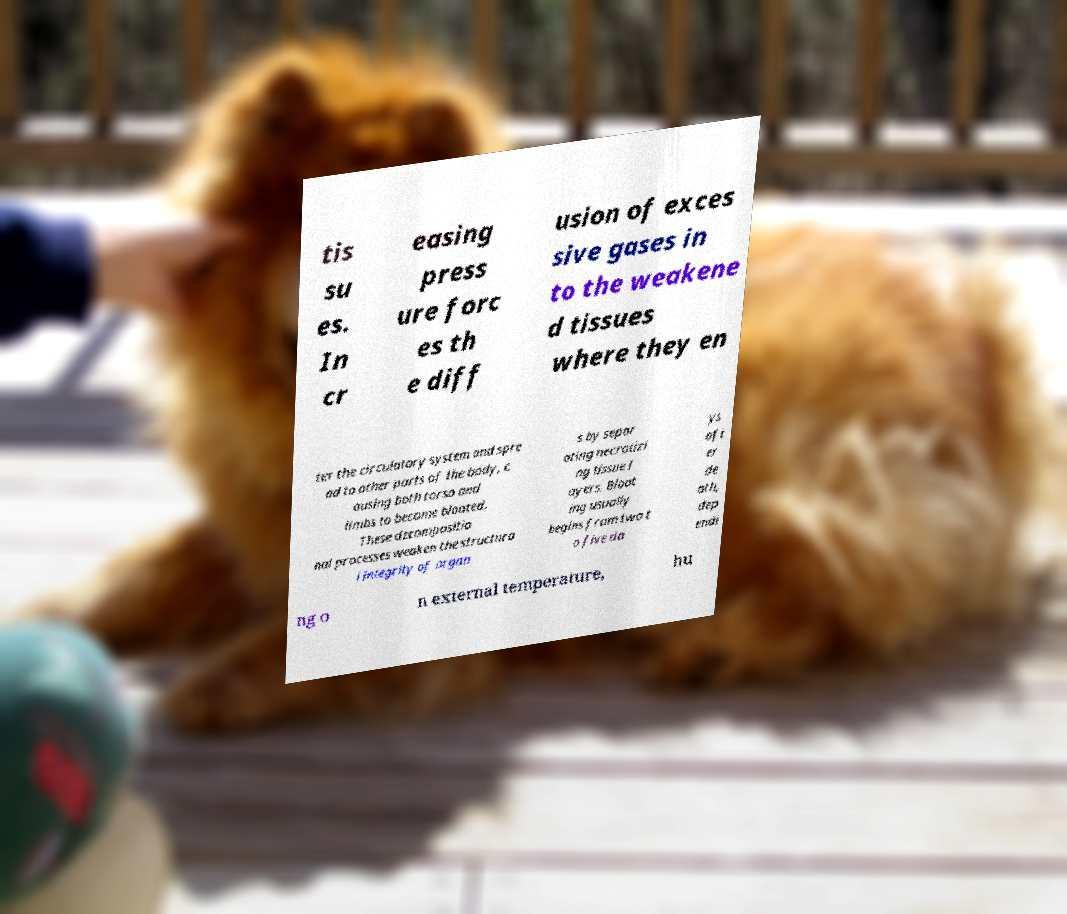Can you read and provide the text displayed in the image?This photo seems to have some interesting text. Can you extract and type it out for me? tis su es. In cr easing press ure forc es th e diff usion of exces sive gases in to the weakene d tissues where they en ter the circulatory system and spre ad to other parts of the body, c ausing both torso and limbs to become bloated. These decompositio nal processes weaken the structura l integrity of organ s by separ ating necrotizi ng tissue l ayers. Bloat ing usually begins from two t o five da ys aft er de ath, dep endi ng o n external temperature, hu 